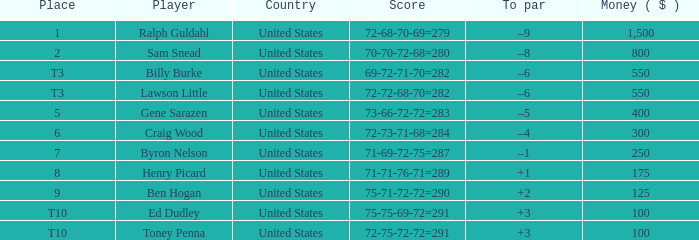Which territory offers a prize below $250 and includes the athlete henry picard? United States. 